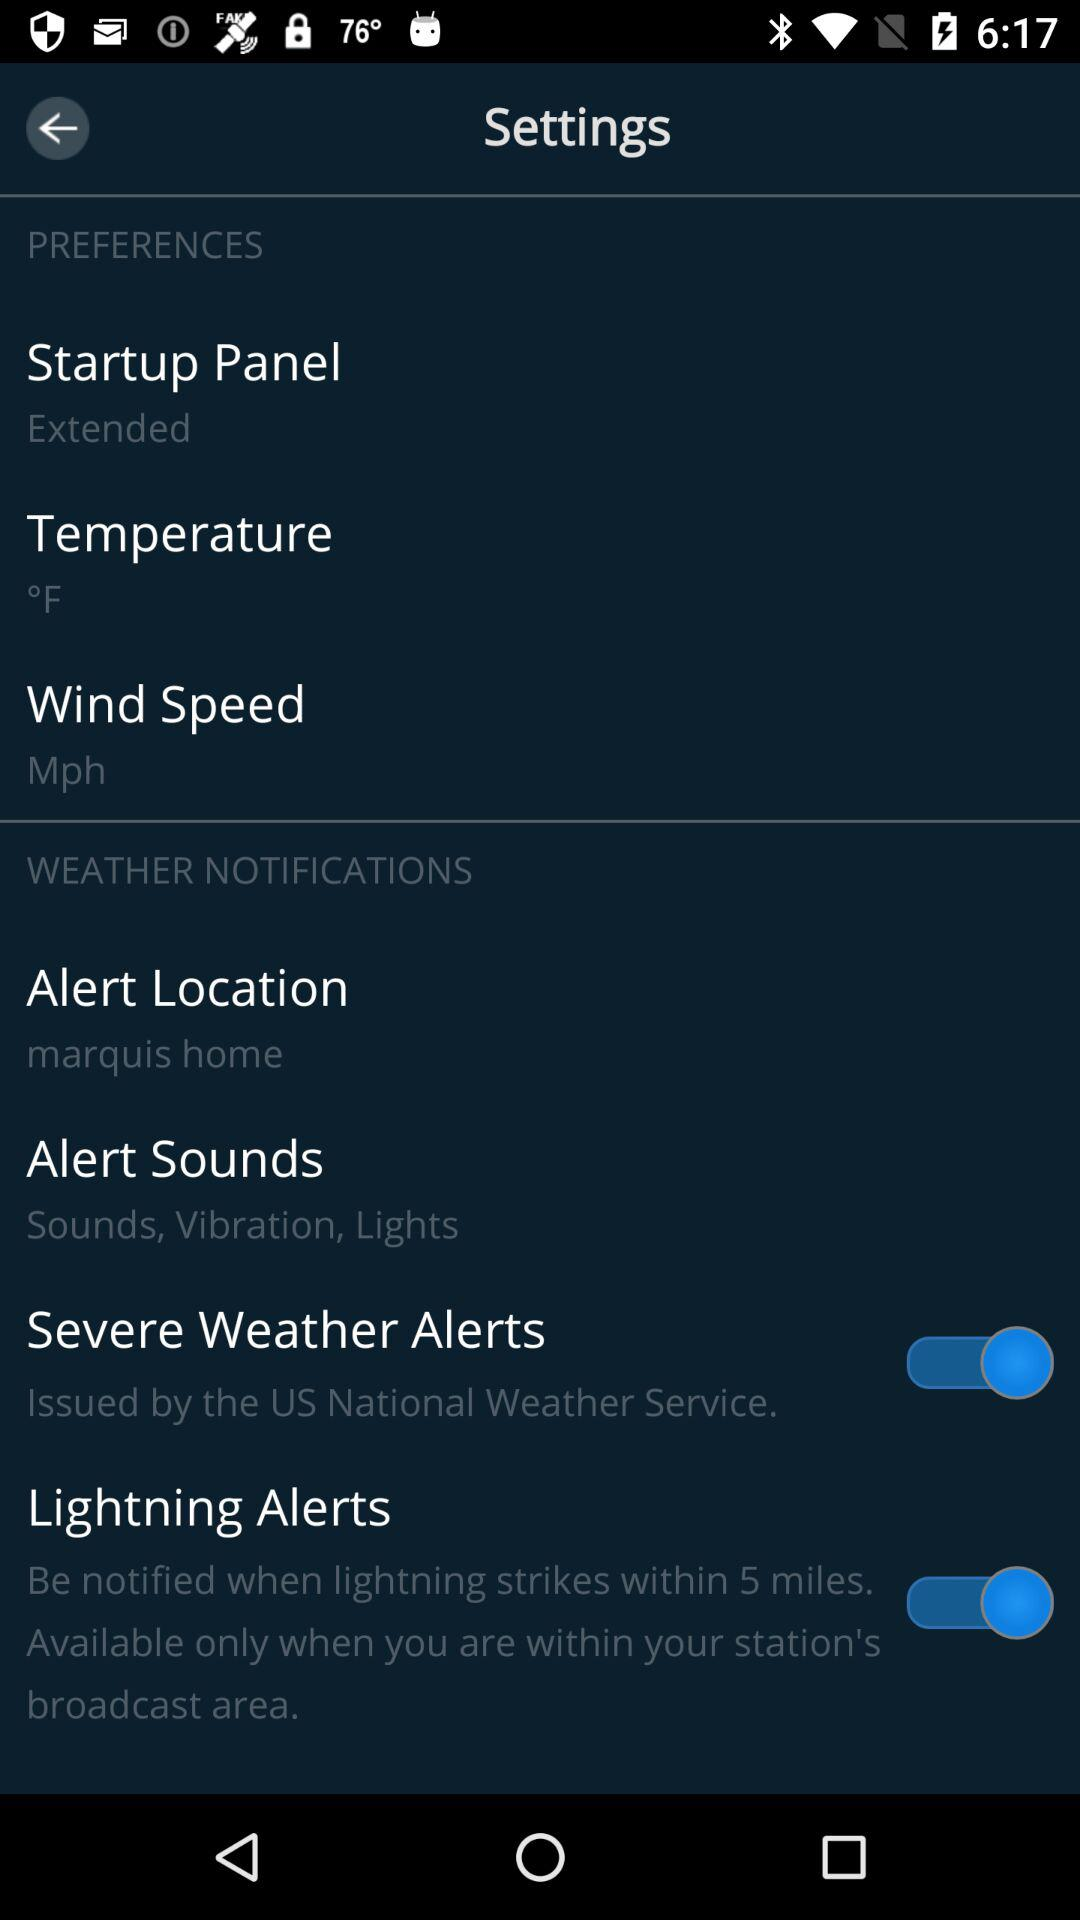What is the setting for alert location? The setting for alert location is "marquis home". 